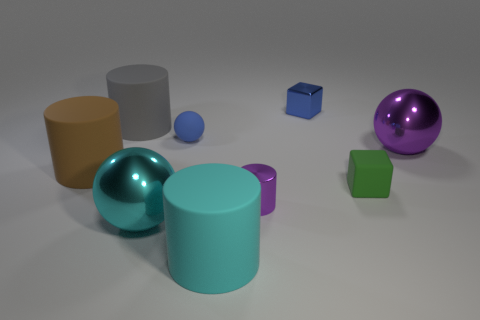If these objects were part of a game, what sort of game could it be and what rules might it involve? Imagining these objects as part of a game, it could be a physics-based puzzle where each shape represents different weights and materials. The game might involve stacking the shapes without them toppling over or using them to solve riddles about weight distribution and material properties. Rules would include a limit on how high you can stack and penalties for causing a collapse. 